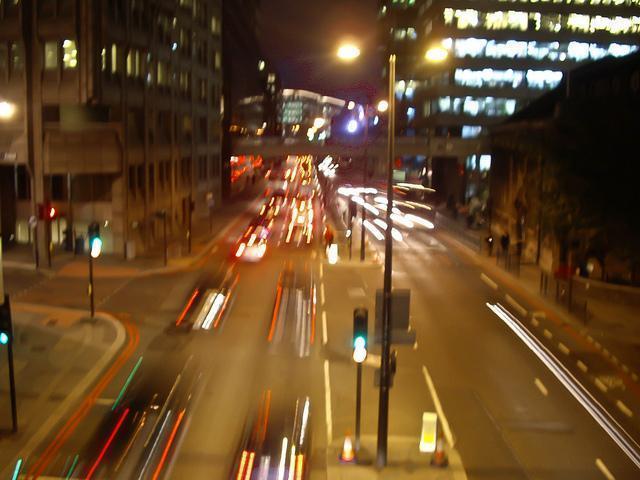What is near the cars?
Choose the right answer from the provided options to respond to the question.
Options: Hose, street lights, cow, garage clerk. Street lights. 